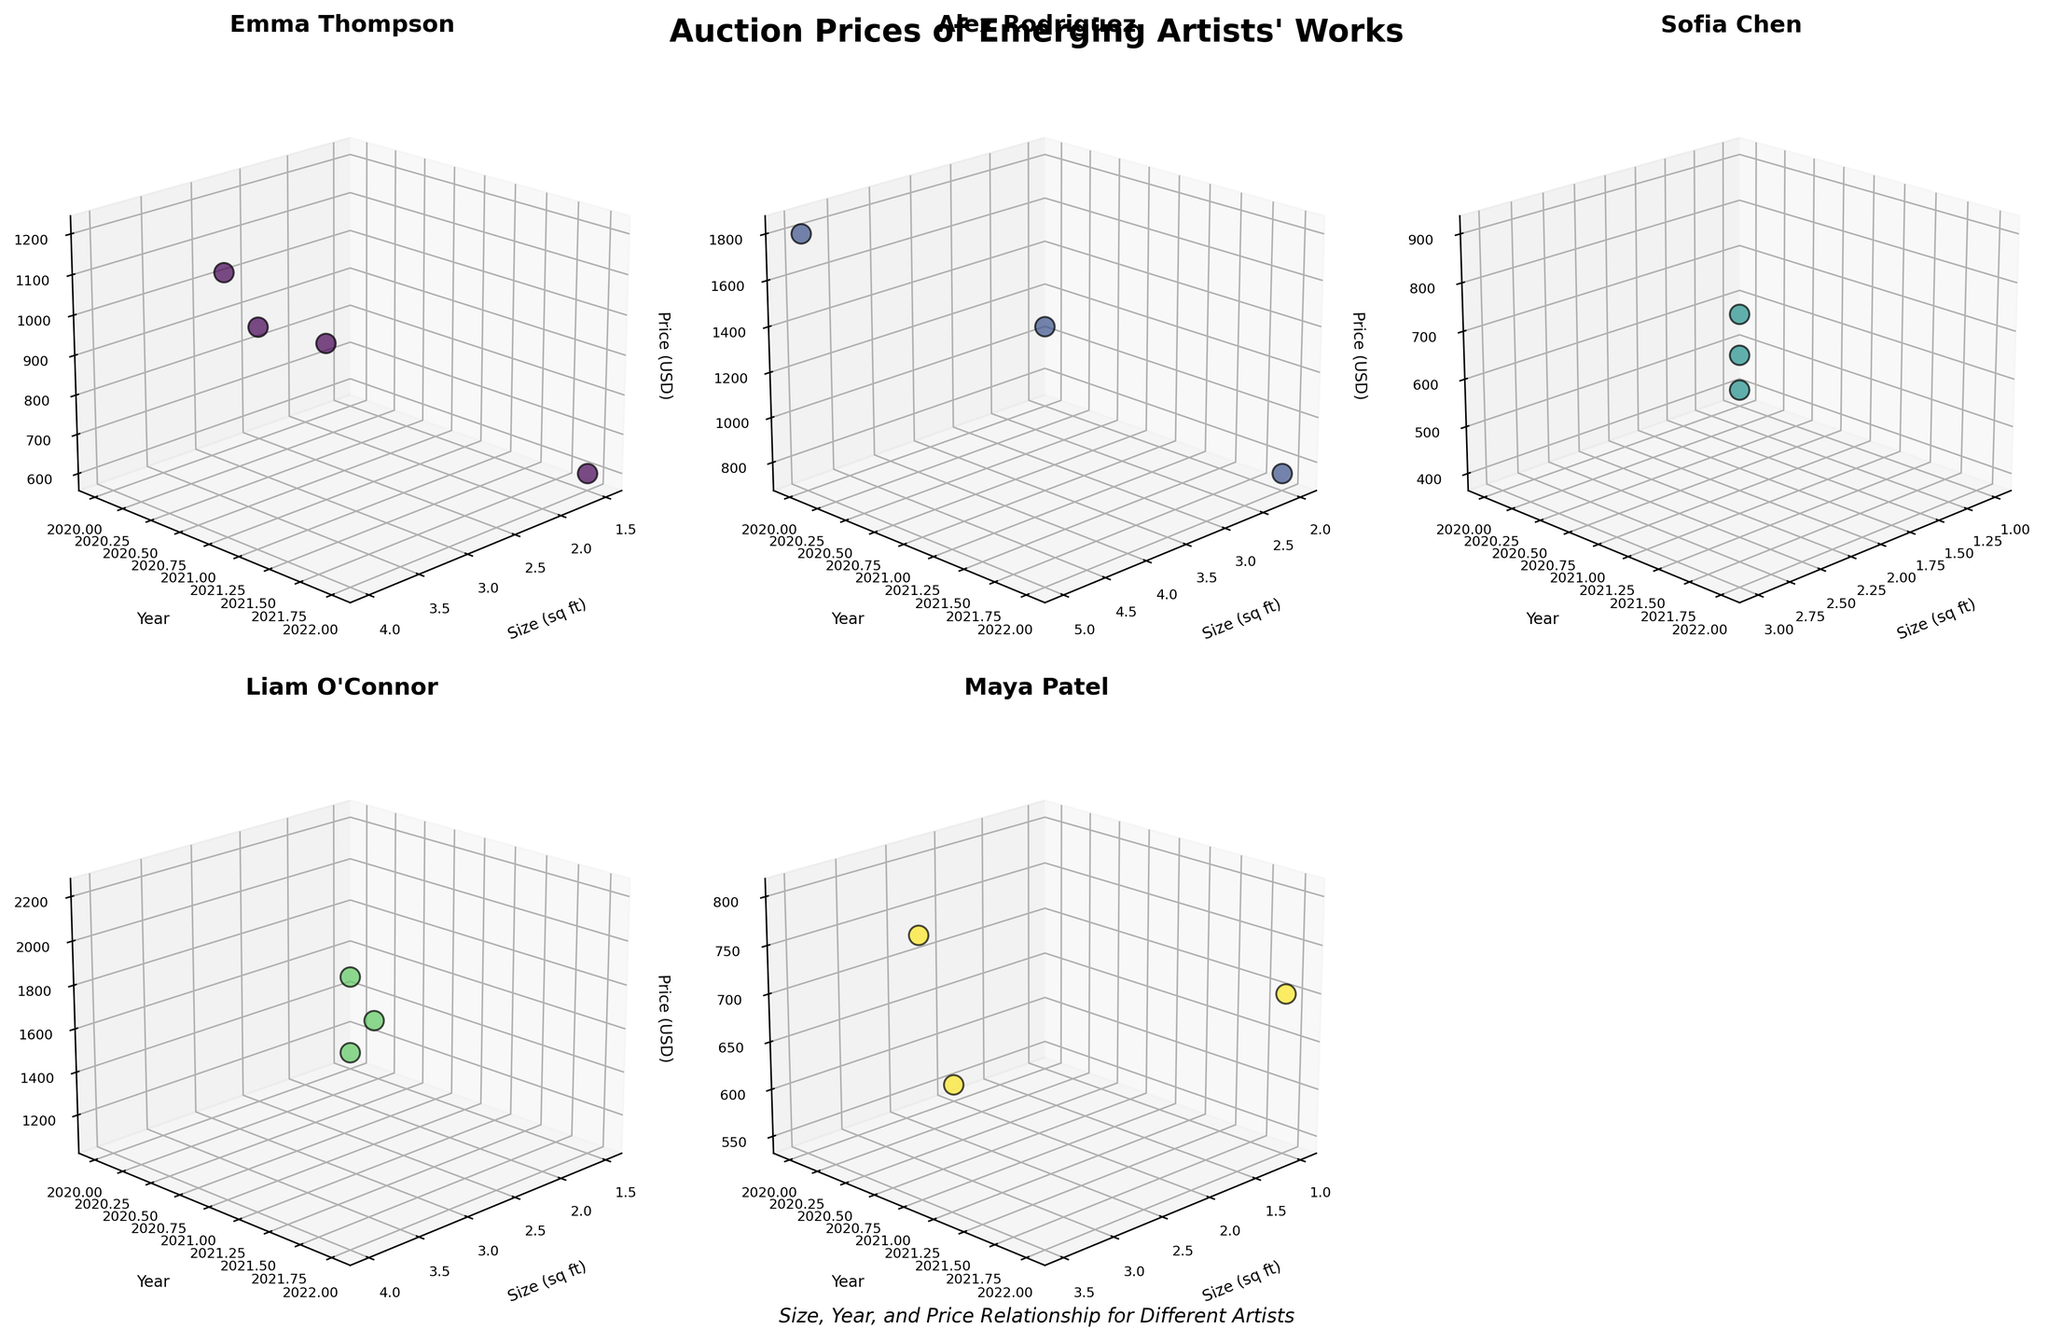How many unique artists are displayed in the figure? By counting the number of individual plots featured for each artist, you can determine the total number of unique artists.
Answer: 5 Which artist has the highest auction price recorded in the figure? Look at the highest points on the price axis (USD) for each subplot, and compare them to find the artist with the highest value.
Answer: Liam O'Connor What's the medium used by the artist with the highest auction price? Find the highest price in Liam O'Connor's subplot and identify the corresponding medium.
Answer: Installation Is there a noticeable trend in auction prices over the years for Emma Thompson? By observing the position of the price points along the time axis (Year) in Emma Thompson's subplot, you can detect if the prices are increasing, decreasing, or remaining stable over time.
Answer: Mixed trend Among the emerging artists, who has the smallest size work that sold for the highest price? Compare the sizes of the artworks in each subplot along with their prices, focusing on the pieces with the smallest size and the highest price concurrently.
Answer: Emma Thompson Which artist has the most data points in their subplot? Count the number of data points scattered in each artist's subplot to identify who has the most.
Answer: Emma Thompson How many pieces did Alex Rodriguez sell in 2021? By looking at the year axis (2021) in Alex Rodriguez's subplot, count the number of data points corresponding to that year.
Answer: 1 Does Maya Patel's work show a consistent increase in auction prices over the years? Observe the data points year by year in Maya Patel's subplot to identify if there's a steady upward trend in prices.
Answer: No What is the average size of artworks sold by Sofia Chen? Add up the sizes (sq ft) of all Sofia Chen's artworks and divide by the number of works to get the average size.
Answer: 2.0 sq ft Which artist's auction prices appear to vary the most over time? By comparing the range of prices (from minimum to maximum) observed over the years in each artist’s subplot, you can determine whose prices show the greatest variation.
Answer: Liam O'Connor 